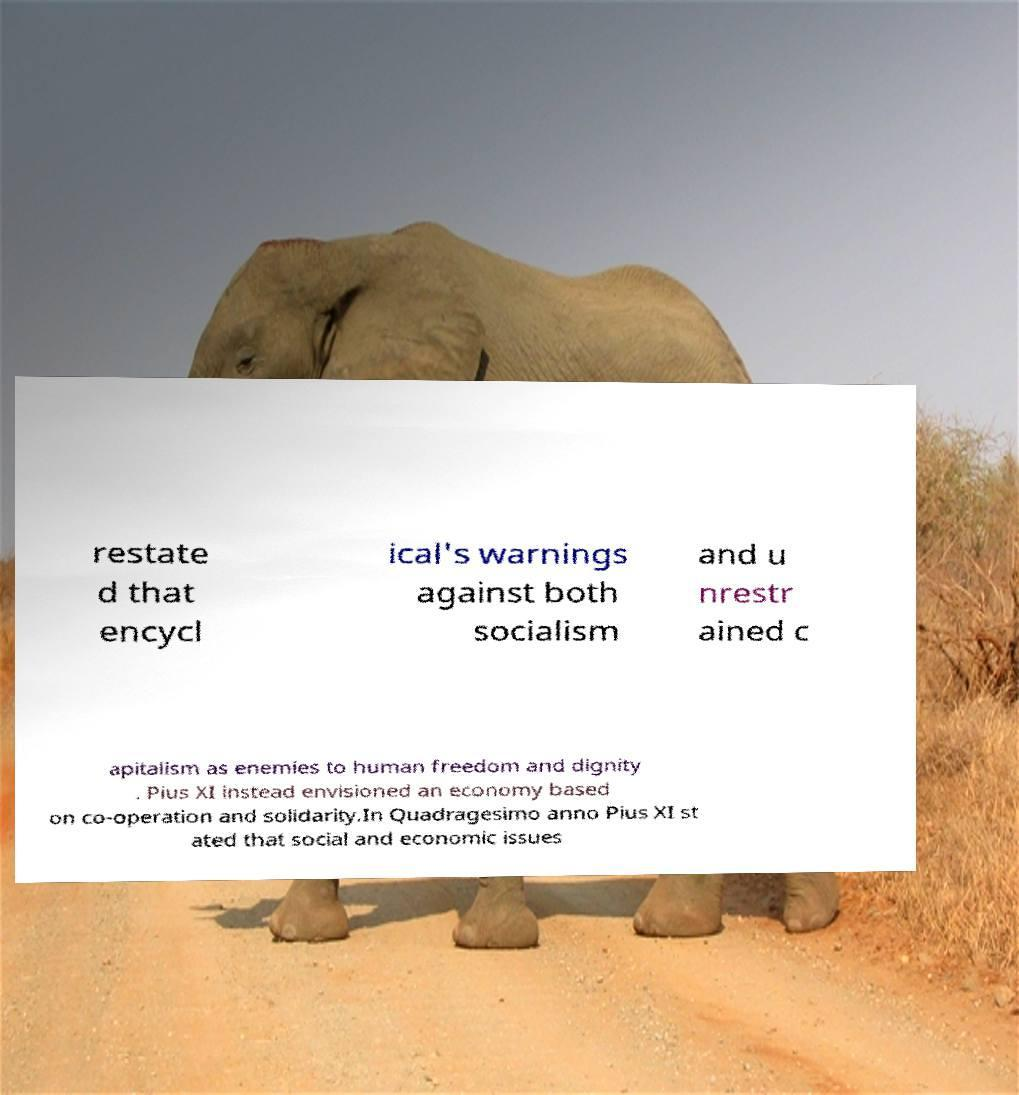Please read and relay the text visible in this image. What does it say? restate d that encycl ical's warnings against both socialism and u nrestr ained c apitalism as enemies to human freedom and dignity . Pius XI instead envisioned an economy based on co-operation and solidarity.In Quadragesimo anno Pius XI st ated that social and economic issues 